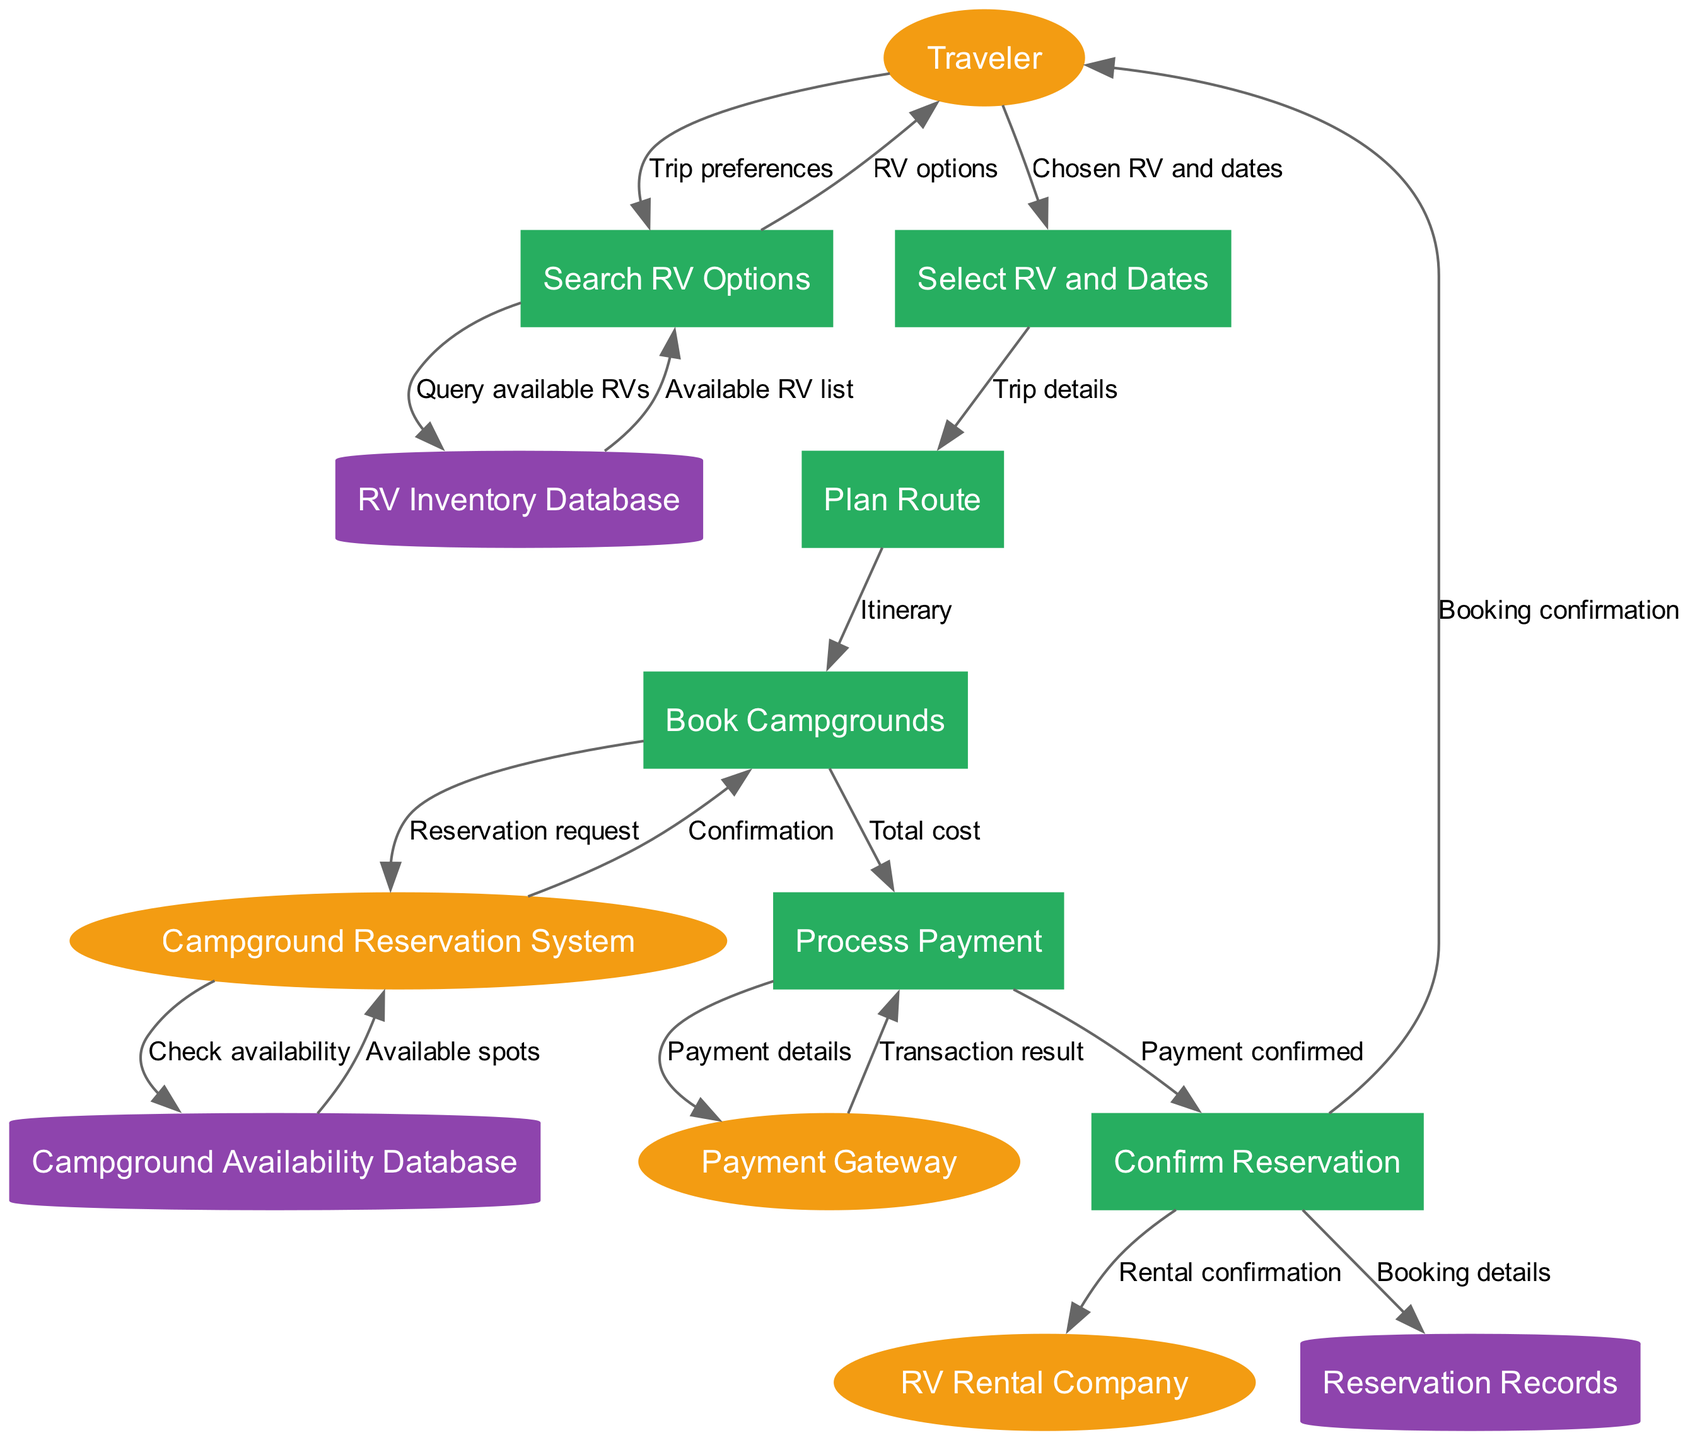What are the external entities in the diagram? The external entities are listed and can be identified as "Traveler", "RV Rental Company", "Campground Reservation System", and "Payment Gateway."
Answer: Traveler, RV Rental Company, Campground Reservation System, Payment Gateway How many processes are involved in the booking flow? By counting the nodes categorized under processes, we find there are six: "Search RV Options", "Select RV and Dates", "Plan Route", "Book Campgrounds", "Process Payment", and "Confirm Reservation."
Answer: 6 What is the first step taken by the traveler? The traveler initiates the process by providing "Trip preferences" as input to the "Search RV Options" process.
Answer: Trip preferences What data store does the "Search RV Options" process query? The "Search RV Options" process queries the "RV Inventory Database" to retrieve information.
Answer: RV Inventory Database What is the final confirmation sent to the traveler? The final confirmation sent to the traveler is labeled as "Booking confirmation" from the "Confirm Reservation" process.
Answer: Booking confirmation Which process receives the "Total cost" as input? The "Process Payment" is the next step that receives "Total cost" after the "Book Campgrounds" process.
Answer: Process Payment How many data flows are there in total? By counting the connections (edges) in the diagram, there are sixteen distinct data flows.
Answer: 16 What does the "Payment Gateway" return to the "Process Payment"? The "Payment Gateway" returns the "Transaction result" to the "Process Payment" process as confirmation of the transaction.
Answer: Transaction result What type of database is the "Campground Availability Database"? The "Campground Availability Database" is categorized as a data store, specifically a database containing campground availability information.
Answer: Campground Availability Database 